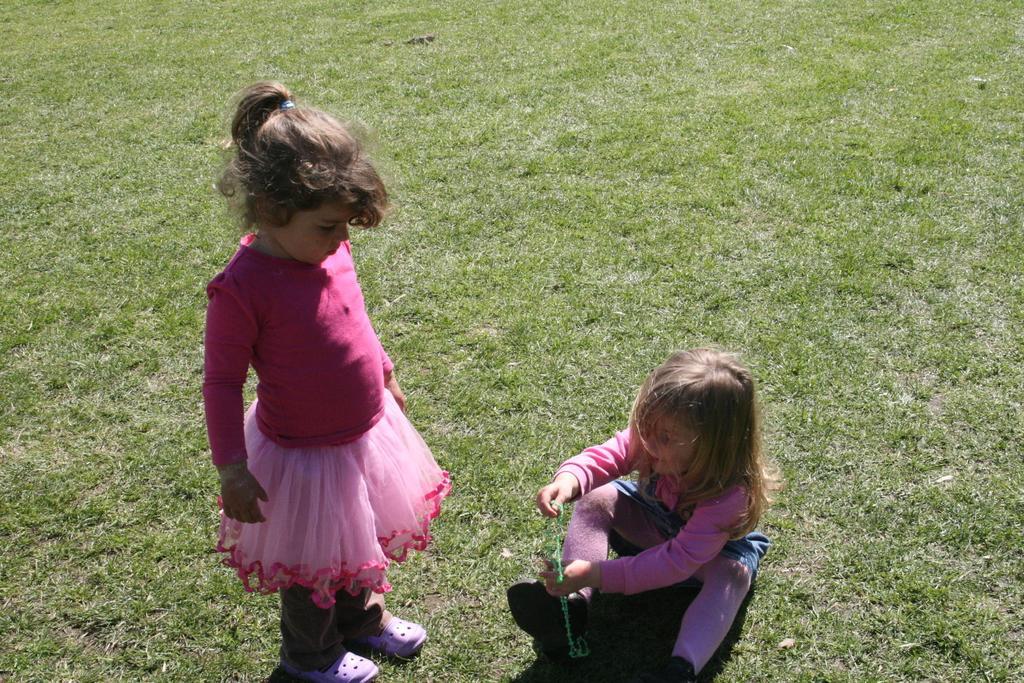How would you summarize this image in a sentence or two? This picture shows a girl seated and a girl standing and we see grass on the ground and a girl wore pink color frock and another girl wore pink color dress. 